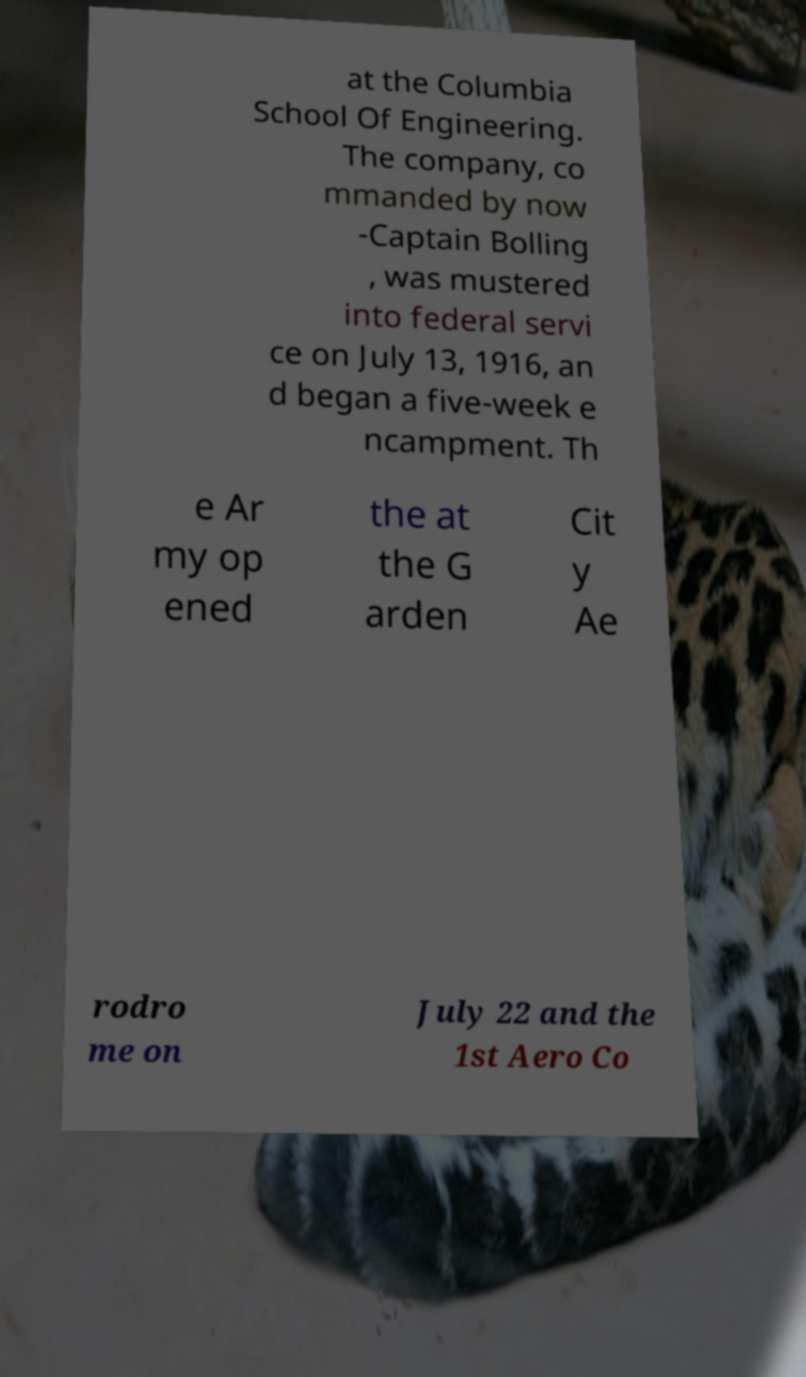I need the written content from this picture converted into text. Can you do that? at the Columbia School Of Engineering. The company, co mmanded by now -Captain Bolling , was mustered into federal servi ce on July 13, 1916, an d began a five-week e ncampment. Th e Ar my op ened the at the G arden Cit y Ae rodro me on July 22 and the 1st Aero Co 